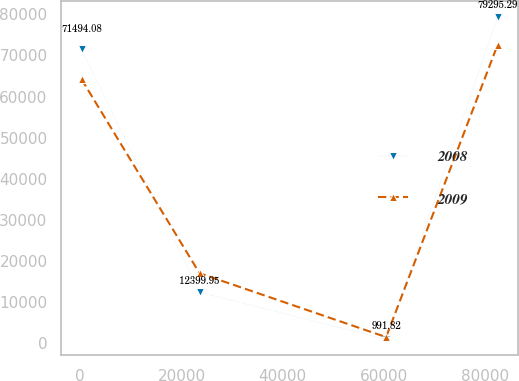Convert chart. <chart><loc_0><loc_0><loc_500><loc_500><line_chart><ecel><fcel>2008<fcel>2009<nl><fcel>256.57<fcel>71494.1<fcel>64198.8<nl><fcel>23564.2<fcel>12400<fcel>17050.9<nl><fcel>60402.7<fcel>991.82<fcel>1520.24<nl><fcel>82415.8<fcel>79295.3<fcel>72566.9<nl></chart> 